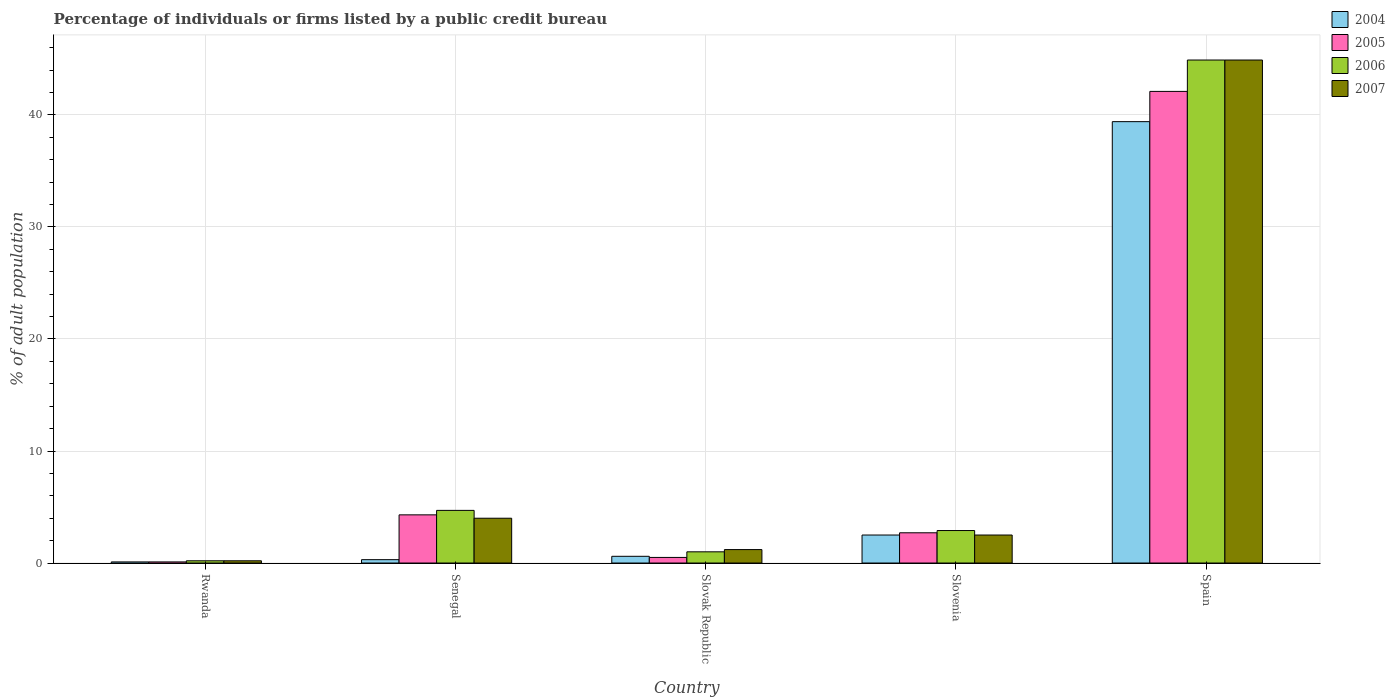How many different coloured bars are there?
Your answer should be compact. 4. Are the number of bars per tick equal to the number of legend labels?
Make the answer very short. Yes. How many bars are there on the 1st tick from the right?
Make the answer very short. 4. What is the label of the 2nd group of bars from the left?
Give a very brief answer. Senegal. Across all countries, what is the maximum percentage of population listed by a public credit bureau in 2006?
Give a very brief answer. 44.9. In which country was the percentage of population listed by a public credit bureau in 2007 maximum?
Provide a succinct answer. Spain. In which country was the percentage of population listed by a public credit bureau in 2004 minimum?
Offer a very short reply. Rwanda. What is the total percentage of population listed by a public credit bureau in 2007 in the graph?
Keep it short and to the point. 52.8. What is the average percentage of population listed by a public credit bureau in 2007 per country?
Offer a very short reply. 10.56. What is the ratio of the percentage of population listed by a public credit bureau in 2006 in Rwanda to that in Senegal?
Provide a short and direct response. 0.04. Is the percentage of population listed by a public credit bureau in 2005 in Rwanda less than that in Slovenia?
Your response must be concise. Yes. Is the difference between the percentage of population listed by a public credit bureau in 2004 in Slovak Republic and Spain greater than the difference between the percentage of population listed by a public credit bureau in 2005 in Slovak Republic and Spain?
Ensure brevity in your answer.  Yes. What is the difference between the highest and the second highest percentage of population listed by a public credit bureau in 2007?
Keep it short and to the point. -42.4. What is the difference between the highest and the lowest percentage of population listed by a public credit bureau in 2006?
Your answer should be compact. 44.7. What does the 4th bar from the left in Slovak Republic represents?
Offer a terse response. 2007. What does the 4th bar from the right in Slovak Republic represents?
Your response must be concise. 2004. How many bars are there?
Keep it short and to the point. 20. Are all the bars in the graph horizontal?
Make the answer very short. No. What is the difference between two consecutive major ticks on the Y-axis?
Provide a short and direct response. 10. Does the graph contain any zero values?
Ensure brevity in your answer.  No. Where does the legend appear in the graph?
Provide a short and direct response. Top right. How many legend labels are there?
Ensure brevity in your answer.  4. What is the title of the graph?
Provide a short and direct response. Percentage of individuals or firms listed by a public credit bureau. Does "1998" appear as one of the legend labels in the graph?
Keep it short and to the point. No. What is the label or title of the X-axis?
Your answer should be compact. Country. What is the label or title of the Y-axis?
Your response must be concise. % of adult population. What is the % of adult population of 2005 in Rwanda?
Your answer should be compact. 0.1. What is the % of adult population in 2006 in Rwanda?
Provide a succinct answer. 0.2. What is the % of adult population in 2007 in Rwanda?
Your response must be concise. 0.2. What is the % of adult population in 2005 in Senegal?
Offer a terse response. 4.3. What is the % of adult population in 2005 in Slovak Republic?
Provide a short and direct response. 0.5. What is the % of adult population in 2006 in Slovak Republic?
Your response must be concise. 1. What is the % of adult population of 2007 in Slovak Republic?
Offer a terse response. 1.2. What is the % of adult population of 2005 in Slovenia?
Offer a very short reply. 2.7. What is the % of adult population of 2004 in Spain?
Provide a short and direct response. 39.4. What is the % of adult population of 2005 in Spain?
Offer a very short reply. 42.1. What is the % of adult population of 2006 in Spain?
Provide a short and direct response. 44.9. What is the % of adult population of 2007 in Spain?
Your response must be concise. 44.9. Across all countries, what is the maximum % of adult population of 2004?
Offer a terse response. 39.4. Across all countries, what is the maximum % of adult population of 2005?
Give a very brief answer. 42.1. Across all countries, what is the maximum % of adult population in 2006?
Offer a terse response. 44.9. Across all countries, what is the maximum % of adult population in 2007?
Provide a succinct answer. 44.9. Across all countries, what is the minimum % of adult population in 2007?
Provide a short and direct response. 0.2. What is the total % of adult population of 2004 in the graph?
Offer a very short reply. 42.9. What is the total % of adult population of 2005 in the graph?
Offer a terse response. 49.7. What is the total % of adult population in 2006 in the graph?
Keep it short and to the point. 53.7. What is the total % of adult population of 2007 in the graph?
Give a very brief answer. 52.8. What is the difference between the % of adult population of 2007 in Rwanda and that in Senegal?
Your response must be concise. -3.8. What is the difference between the % of adult population of 2004 in Rwanda and that in Slovenia?
Offer a very short reply. -2.4. What is the difference between the % of adult population in 2006 in Rwanda and that in Slovenia?
Offer a very short reply. -2.7. What is the difference between the % of adult population in 2007 in Rwanda and that in Slovenia?
Provide a succinct answer. -2.3. What is the difference between the % of adult population of 2004 in Rwanda and that in Spain?
Your answer should be very brief. -39.3. What is the difference between the % of adult population in 2005 in Rwanda and that in Spain?
Ensure brevity in your answer.  -42. What is the difference between the % of adult population in 2006 in Rwanda and that in Spain?
Provide a short and direct response. -44.7. What is the difference between the % of adult population of 2007 in Rwanda and that in Spain?
Give a very brief answer. -44.7. What is the difference between the % of adult population of 2005 in Senegal and that in Slovak Republic?
Offer a very short reply. 3.8. What is the difference between the % of adult population of 2007 in Senegal and that in Slovak Republic?
Your answer should be compact. 2.8. What is the difference between the % of adult population in 2005 in Senegal and that in Slovenia?
Your response must be concise. 1.6. What is the difference between the % of adult population in 2004 in Senegal and that in Spain?
Offer a terse response. -39.1. What is the difference between the % of adult population of 2005 in Senegal and that in Spain?
Your answer should be very brief. -37.8. What is the difference between the % of adult population in 2006 in Senegal and that in Spain?
Your answer should be very brief. -40.2. What is the difference between the % of adult population in 2007 in Senegal and that in Spain?
Ensure brevity in your answer.  -40.9. What is the difference between the % of adult population of 2005 in Slovak Republic and that in Slovenia?
Your answer should be compact. -2.2. What is the difference between the % of adult population of 2006 in Slovak Republic and that in Slovenia?
Provide a short and direct response. -1.9. What is the difference between the % of adult population of 2007 in Slovak Republic and that in Slovenia?
Make the answer very short. -1.3. What is the difference between the % of adult population of 2004 in Slovak Republic and that in Spain?
Keep it short and to the point. -38.8. What is the difference between the % of adult population in 2005 in Slovak Republic and that in Spain?
Offer a terse response. -41.6. What is the difference between the % of adult population in 2006 in Slovak Republic and that in Spain?
Provide a short and direct response. -43.9. What is the difference between the % of adult population of 2007 in Slovak Republic and that in Spain?
Offer a terse response. -43.7. What is the difference between the % of adult population of 2004 in Slovenia and that in Spain?
Offer a very short reply. -36.9. What is the difference between the % of adult population of 2005 in Slovenia and that in Spain?
Your answer should be compact. -39.4. What is the difference between the % of adult population of 2006 in Slovenia and that in Spain?
Give a very brief answer. -42. What is the difference between the % of adult population in 2007 in Slovenia and that in Spain?
Make the answer very short. -42.4. What is the difference between the % of adult population of 2005 in Rwanda and the % of adult population of 2007 in Senegal?
Make the answer very short. -3.9. What is the difference between the % of adult population of 2004 in Rwanda and the % of adult population of 2005 in Slovak Republic?
Ensure brevity in your answer.  -0.4. What is the difference between the % of adult population of 2004 in Rwanda and the % of adult population of 2006 in Slovak Republic?
Your answer should be very brief. -0.9. What is the difference between the % of adult population in 2006 in Rwanda and the % of adult population in 2007 in Slovak Republic?
Offer a terse response. -1. What is the difference between the % of adult population in 2004 in Rwanda and the % of adult population in 2005 in Slovenia?
Give a very brief answer. -2.6. What is the difference between the % of adult population of 2005 in Rwanda and the % of adult population of 2007 in Slovenia?
Your answer should be compact. -2.4. What is the difference between the % of adult population of 2004 in Rwanda and the % of adult population of 2005 in Spain?
Provide a short and direct response. -42. What is the difference between the % of adult population in 2004 in Rwanda and the % of adult population in 2006 in Spain?
Your answer should be very brief. -44.8. What is the difference between the % of adult population in 2004 in Rwanda and the % of adult population in 2007 in Spain?
Keep it short and to the point. -44.8. What is the difference between the % of adult population of 2005 in Rwanda and the % of adult population of 2006 in Spain?
Give a very brief answer. -44.8. What is the difference between the % of adult population of 2005 in Rwanda and the % of adult population of 2007 in Spain?
Ensure brevity in your answer.  -44.8. What is the difference between the % of adult population in 2006 in Rwanda and the % of adult population in 2007 in Spain?
Keep it short and to the point. -44.7. What is the difference between the % of adult population of 2004 in Senegal and the % of adult population of 2005 in Slovak Republic?
Provide a succinct answer. -0.2. What is the difference between the % of adult population in 2004 in Senegal and the % of adult population in 2006 in Slovak Republic?
Your response must be concise. -0.7. What is the difference between the % of adult population of 2004 in Senegal and the % of adult population of 2007 in Slovak Republic?
Offer a very short reply. -0.9. What is the difference between the % of adult population in 2005 in Senegal and the % of adult population in 2006 in Slovak Republic?
Offer a terse response. 3.3. What is the difference between the % of adult population in 2005 in Senegal and the % of adult population in 2007 in Slovak Republic?
Provide a short and direct response. 3.1. What is the difference between the % of adult population of 2006 in Senegal and the % of adult population of 2007 in Slovak Republic?
Provide a short and direct response. 3.5. What is the difference between the % of adult population of 2006 in Senegal and the % of adult population of 2007 in Slovenia?
Your answer should be compact. 2.2. What is the difference between the % of adult population of 2004 in Senegal and the % of adult population of 2005 in Spain?
Offer a terse response. -41.8. What is the difference between the % of adult population of 2004 in Senegal and the % of adult population of 2006 in Spain?
Provide a succinct answer. -44.6. What is the difference between the % of adult population of 2004 in Senegal and the % of adult population of 2007 in Spain?
Your answer should be very brief. -44.6. What is the difference between the % of adult population in 2005 in Senegal and the % of adult population in 2006 in Spain?
Make the answer very short. -40.6. What is the difference between the % of adult population in 2005 in Senegal and the % of adult population in 2007 in Spain?
Your answer should be very brief. -40.6. What is the difference between the % of adult population in 2006 in Senegal and the % of adult population in 2007 in Spain?
Ensure brevity in your answer.  -40.2. What is the difference between the % of adult population in 2004 in Slovak Republic and the % of adult population in 2007 in Slovenia?
Provide a succinct answer. -1.9. What is the difference between the % of adult population in 2005 in Slovak Republic and the % of adult population in 2006 in Slovenia?
Your answer should be compact. -2.4. What is the difference between the % of adult population in 2005 in Slovak Republic and the % of adult population in 2007 in Slovenia?
Give a very brief answer. -2. What is the difference between the % of adult population of 2006 in Slovak Republic and the % of adult population of 2007 in Slovenia?
Your answer should be very brief. -1.5. What is the difference between the % of adult population of 2004 in Slovak Republic and the % of adult population of 2005 in Spain?
Make the answer very short. -41.5. What is the difference between the % of adult population of 2004 in Slovak Republic and the % of adult population of 2006 in Spain?
Provide a succinct answer. -44.3. What is the difference between the % of adult population in 2004 in Slovak Republic and the % of adult population in 2007 in Spain?
Keep it short and to the point. -44.3. What is the difference between the % of adult population in 2005 in Slovak Republic and the % of adult population in 2006 in Spain?
Your response must be concise. -44.4. What is the difference between the % of adult population in 2005 in Slovak Republic and the % of adult population in 2007 in Spain?
Offer a very short reply. -44.4. What is the difference between the % of adult population in 2006 in Slovak Republic and the % of adult population in 2007 in Spain?
Your response must be concise. -43.9. What is the difference between the % of adult population in 2004 in Slovenia and the % of adult population in 2005 in Spain?
Your answer should be very brief. -39.6. What is the difference between the % of adult population of 2004 in Slovenia and the % of adult population of 2006 in Spain?
Keep it short and to the point. -42.4. What is the difference between the % of adult population of 2004 in Slovenia and the % of adult population of 2007 in Spain?
Provide a short and direct response. -42.4. What is the difference between the % of adult population of 2005 in Slovenia and the % of adult population of 2006 in Spain?
Give a very brief answer. -42.2. What is the difference between the % of adult population in 2005 in Slovenia and the % of adult population in 2007 in Spain?
Your response must be concise. -42.2. What is the difference between the % of adult population of 2006 in Slovenia and the % of adult population of 2007 in Spain?
Your answer should be very brief. -42. What is the average % of adult population in 2004 per country?
Make the answer very short. 8.58. What is the average % of adult population of 2005 per country?
Keep it short and to the point. 9.94. What is the average % of adult population in 2006 per country?
Your answer should be very brief. 10.74. What is the average % of adult population of 2007 per country?
Make the answer very short. 10.56. What is the difference between the % of adult population in 2004 and % of adult population in 2005 in Rwanda?
Provide a short and direct response. 0. What is the difference between the % of adult population of 2004 and % of adult population of 2007 in Rwanda?
Provide a succinct answer. -0.1. What is the difference between the % of adult population in 2005 and % of adult population in 2007 in Rwanda?
Your answer should be compact. -0.1. What is the difference between the % of adult population in 2006 and % of adult population in 2007 in Rwanda?
Make the answer very short. 0. What is the difference between the % of adult population in 2004 and % of adult population in 2005 in Senegal?
Give a very brief answer. -4. What is the difference between the % of adult population in 2005 and % of adult population in 2006 in Senegal?
Offer a terse response. -0.4. What is the difference between the % of adult population of 2005 and % of adult population of 2007 in Slovak Republic?
Keep it short and to the point. -0.7. What is the difference between the % of adult population of 2006 and % of adult population of 2007 in Slovak Republic?
Offer a terse response. -0.2. What is the difference between the % of adult population of 2004 and % of adult population of 2005 in Slovenia?
Give a very brief answer. -0.2. What is the difference between the % of adult population in 2004 and % of adult population in 2007 in Slovenia?
Your response must be concise. 0. What is the difference between the % of adult population of 2005 and % of adult population of 2007 in Slovenia?
Offer a very short reply. 0.2. What is the difference between the % of adult population in 2004 and % of adult population in 2007 in Spain?
Your answer should be very brief. -5.5. What is the difference between the % of adult population of 2005 and % of adult population of 2006 in Spain?
Your response must be concise. -2.8. What is the ratio of the % of adult population in 2005 in Rwanda to that in Senegal?
Your answer should be compact. 0.02. What is the ratio of the % of adult population in 2006 in Rwanda to that in Senegal?
Provide a short and direct response. 0.04. What is the ratio of the % of adult population of 2007 in Rwanda to that in Senegal?
Your response must be concise. 0.05. What is the ratio of the % of adult population in 2005 in Rwanda to that in Slovenia?
Your answer should be compact. 0.04. What is the ratio of the % of adult population in 2006 in Rwanda to that in Slovenia?
Offer a terse response. 0.07. What is the ratio of the % of adult population in 2007 in Rwanda to that in Slovenia?
Provide a short and direct response. 0.08. What is the ratio of the % of adult population in 2004 in Rwanda to that in Spain?
Keep it short and to the point. 0. What is the ratio of the % of adult population of 2005 in Rwanda to that in Spain?
Your answer should be compact. 0. What is the ratio of the % of adult population in 2006 in Rwanda to that in Spain?
Offer a very short reply. 0. What is the ratio of the % of adult population in 2007 in Rwanda to that in Spain?
Offer a terse response. 0. What is the ratio of the % of adult population in 2004 in Senegal to that in Slovak Republic?
Provide a succinct answer. 0.5. What is the ratio of the % of adult population in 2005 in Senegal to that in Slovak Republic?
Your response must be concise. 8.6. What is the ratio of the % of adult population in 2007 in Senegal to that in Slovak Republic?
Keep it short and to the point. 3.33. What is the ratio of the % of adult population in 2004 in Senegal to that in Slovenia?
Your answer should be very brief. 0.12. What is the ratio of the % of adult population in 2005 in Senegal to that in Slovenia?
Provide a succinct answer. 1.59. What is the ratio of the % of adult population of 2006 in Senegal to that in Slovenia?
Ensure brevity in your answer.  1.62. What is the ratio of the % of adult population of 2004 in Senegal to that in Spain?
Ensure brevity in your answer.  0.01. What is the ratio of the % of adult population of 2005 in Senegal to that in Spain?
Keep it short and to the point. 0.1. What is the ratio of the % of adult population in 2006 in Senegal to that in Spain?
Offer a very short reply. 0.1. What is the ratio of the % of adult population of 2007 in Senegal to that in Spain?
Keep it short and to the point. 0.09. What is the ratio of the % of adult population in 2004 in Slovak Republic to that in Slovenia?
Ensure brevity in your answer.  0.24. What is the ratio of the % of adult population of 2005 in Slovak Republic to that in Slovenia?
Keep it short and to the point. 0.19. What is the ratio of the % of adult population of 2006 in Slovak Republic to that in Slovenia?
Make the answer very short. 0.34. What is the ratio of the % of adult population in 2007 in Slovak Republic to that in Slovenia?
Offer a very short reply. 0.48. What is the ratio of the % of adult population of 2004 in Slovak Republic to that in Spain?
Ensure brevity in your answer.  0.02. What is the ratio of the % of adult population of 2005 in Slovak Republic to that in Spain?
Give a very brief answer. 0.01. What is the ratio of the % of adult population in 2006 in Slovak Republic to that in Spain?
Your answer should be compact. 0.02. What is the ratio of the % of adult population in 2007 in Slovak Republic to that in Spain?
Ensure brevity in your answer.  0.03. What is the ratio of the % of adult population in 2004 in Slovenia to that in Spain?
Your answer should be very brief. 0.06. What is the ratio of the % of adult population of 2005 in Slovenia to that in Spain?
Provide a short and direct response. 0.06. What is the ratio of the % of adult population in 2006 in Slovenia to that in Spain?
Offer a terse response. 0.06. What is the ratio of the % of adult population of 2007 in Slovenia to that in Spain?
Offer a terse response. 0.06. What is the difference between the highest and the second highest % of adult population of 2004?
Make the answer very short. 36.9. What is the difference between the highest and the second highest % of adult population in 2005?
Provide a succinct answer. 37.8. What is the difference between the highest and the second highest % of adult population of 2006?
Make the answer very short. 40.2. What is the difference between the highest and the second highest % of adult population of 2007?
Ensure brevity in your answer.  40.9. What is the difference between the highest and the lowest % of adult population in 2004?
Offer a terse response. 39.3. What is the difference between the highest and the lowest % of adult population in 2005?
Ensure brevity in your answer.  42. What is the difference between the highest and the lowest % of adult population of 2006?
Keep it short and to the point. 44.7. What is the difference between the highest and the lowest % of adult population of 2007?
Ensure brevity in your answer.  44.7. 